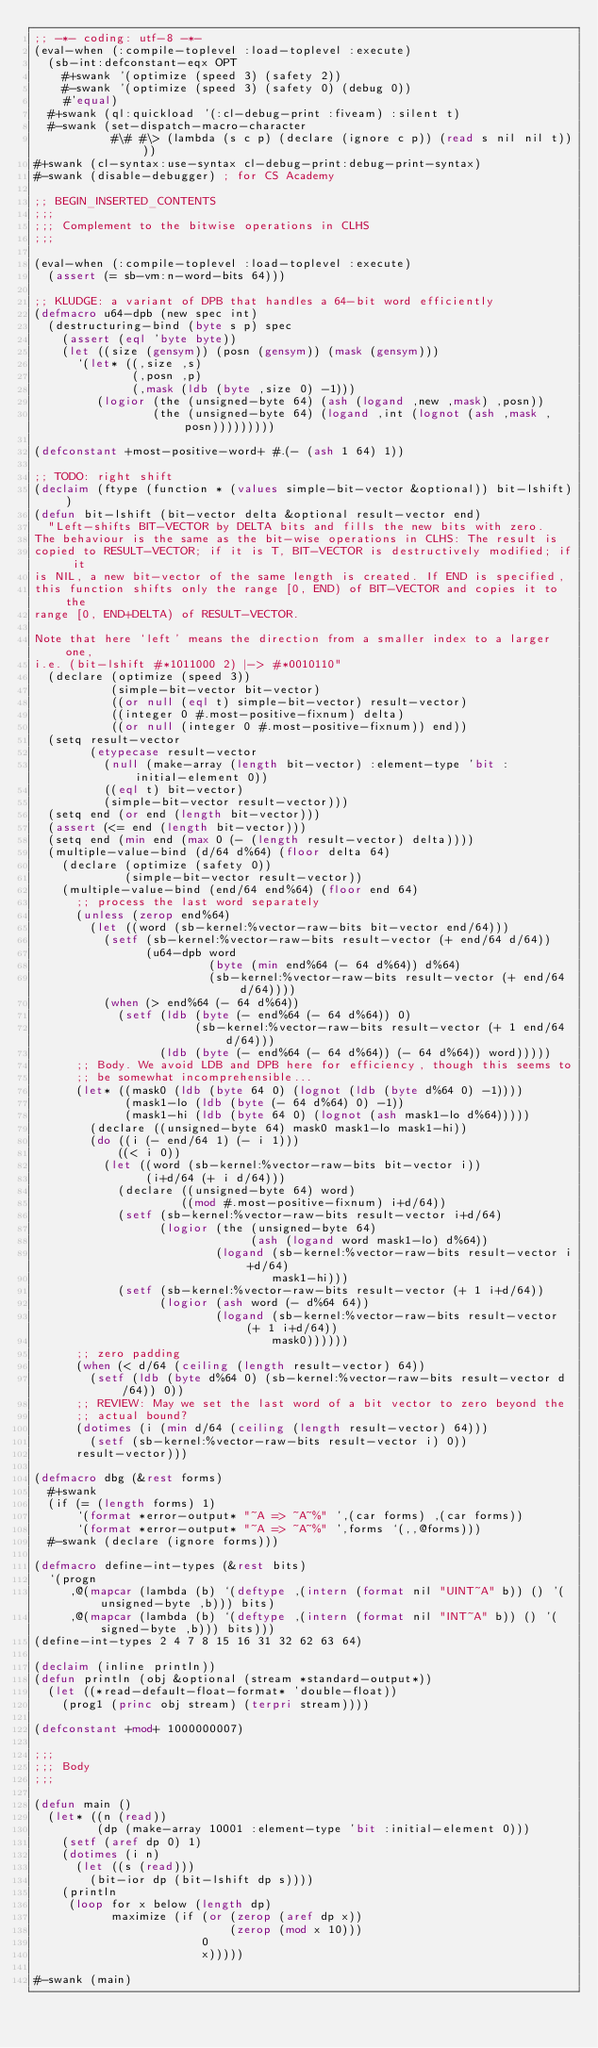Convert code to text. <code><loc_0><loc_0><loc_500><loc_500><_Lisp_>;; -*- coding: utf-8 -*-
(eval-when (:compile-toplevel :load-toplevel :execute)
  (sb-int:defconstant-eqx OPT
    #+swank '(optimize (speed 3) (safety 2))
    #-swank '(optimize (speed 3) (safety 0) (debug 0))
    #'equal)
  #+swank (ql:quickload '(:cl-debug-print :fiveam) :silent t)
  #-swank (set-dispatch-macro-character
           #\# #\> (lambda (s c p) (declare (ignore c p)) (read s nil nil t))))
#+swank (cl-syntax:use-syntax cl-debug-print:debug-print-syntax)
#-swank (disable-debugger) ; for CS Academy

;; BEGIN_INSERTED_CONTENTS
;;;
;;; Complement to the bitwise operations in CLHS
;;;

(eval-when (:compile-toplevel :load-toplevel :execute)
  (assert (= sb-vm:n-word-bits 64)))

;; KLUDGE: a variant of DPB that handles a 64-bit word efficiently
(defmacro u64-dpb (new spec int)
  (destructuring-bind (byte s p) spec
    (assert (eql 'byte byte))
    (let ((size (gensym)) (posn (gensym)) (mask (gensym)))
      `(let* ((,size ,s)
              (,posn ,p)
              (,mask (ldb (byte ,size 0) -1)))
         (logior (the (unsigned-byte 64) (ash (logand ,new ,mask) ,posn))
                 (the (unsigned-byte 64) (logand ,int (lognot (ash ,mask ,posn)))))))))

(defconstant +most-positive-word+ #.(- (ash 1 64) 1))

;; TODO: right shift
(declaim (ftype (function * (values simple-bit-vector &optional)) bit-lshift))
(defun bit-lshift (bit-vector delta &optional result-vector end)
  "Left-shifts BIT-VECTOR by DELTA bits and fills the new bits with zero.
The behaviour is the same as the bit-wise operations in CLHS: The result is
copied to RESULT-VECTOR; if it is T, BIT-VECTOR is destructively modified; if it
is NIL, a new bit-vector of the same length is created. If END is specified,
this function shifts only the range [0, END) of BIT-VECTOR and copies it to the
range [0, END+DELTA) of RESULT-VECTOR.

Note that here `left' means the direction from a smaller index to a larger one,
i.e. (bit-lshift #*1011000 2) |-> #*0010110"
  (declare (optimize (speed 3))
           (simple-bit-vector bit-vector)
           ((or null (eql t) simple-bit-vector) result-vector)
           ((integer 0 #.most-positive-fixnum) delta)
           ((or null (integer 0 #.most-positive-fixnum)) end))
  (setq result-vector
        (etypecase result-vector
          (null (make-array (length bit-vector) :element-type 'bit :initial-element 0))
          ((eql t) bit-vector)
          (simple-bit-vector result-vector)))
  (setq end (or end (length bit-vector)))
  (assert (<= end (length bit-vector)))
  (setq end (min end (max 0 (- (length result-vector) delta))))
  (multiple-value-bind (d/64 d%64) (floor delta 64)
    (declare (optimize (safety 0))
             (simple-bit-vector result-vector))
    (multiple-value-bind (end/64 end%64) (floor end 64)
      ;; process the last word separately
      (unless (zerop end%64)
        (let ((word (sb-kernel:%vector-raw-bits bit-vector end/64)))
          (setf (sb-kernel:%vector-raw-bits result-vector (+ end/64 d/64))
                (u64-dpb word
                         (byte (min end%64 (- 64 d%64)) d%64)
                         (sb-kernel:%vector-raw-bits result-vector (+ end/64 d/64))))
          (when (> end%64 (- 64 d%64))
            (setf (ldb (byte (- end%64 (- 64 d%64)) 0)
                       (sb-kernel:%vector-raw-bits result-vector (+ 1 end/64 d/64)))
                  (ldb (byte (- end%64 (- 64 d%64)) (- 64 d%64)) word)))))
      ;; Body. We avoid LDB and DPB here for efficiency, though this seems to
      ;; be somewhat incomprehensible...
      (let* ((mask0 (ldb (byte 64 0) (lognot (ldb (byte d%64 0) -1))))
             (mask1-lo (ldb (byte (- 64 d%64) 0) -1))
             (mask1-hi (ldb (byte 64 0) (lognot (ash mask1-lo d%64)))))
        (declare ((unsigned-byte 64) mask0 mask1-lo mask1-hi))
        (do ((i (- end/64 1) (- i 1)))
            ((< i 0))
          (let ((word (sb-kernel:%vector-raw-bits bit-vector i))
                (i+d/64 (+ i d/64)))
            (declare ((unsigned-byte 64) word)
                     ((mod #.most-positive-fixnum) i+d/64))
            (setf (sb-kernel:%vector-raw-bits result-vector i+d/64)
                  (logior (the (unsigned-byte 64)
                               (ash (logand word mask1-lo) d%64))
                          (logand (sb-kernel:%vector-raw-bits result-vector i+d/64)
                                  mask1-hi)))
            (setf (sb-kernel:%vector-raw-bits result-vector (+ 1 i+d/64))
                  (logior (ash word (- d%64 64))
                          (logand (sb-kernel:%vector-raw-bits result-vector (+ 1 i+d/64))
                                  mask0))))))
      ;; zero padding
      (when (< d/64 (ceiling (length result-vector) 64))
        (setf (ldb (byte d%64 0) (sb-kernel:%vector-raw-bits result-vector d/64)) 0))
      ;; REVIEW: May we set the last word of a bit vector to zero beyond the
      ;; actual bound?
      (dotimes (i (min d/64 (ceiling (length result-vector) 64)))
        (setf (sb-kernel:%vector-raw-bits result-vector i) 0))
      result-vector)))

(defmacro dbg (&rest forms)
  #+swank
  (if (= (length forms) 1)
      `(format *error-output* "~A => ~A~%" ',(car forms) ,(car forms))
      `(format *error-output* "~A => ~A~%" ',forms `(,,@forms)))
  #-swank (declare (ignore forms)))

(defmacro define-int-types (&rest bits)
  `(progn
     ,@(mapcar (lambda (b) `(deftype ,(intern (format nil "UINT~A" b)) () '(unsigned-byte ,b))) bits)
     ,@(mapcar (lambda (b) `(deftype ,(intern (format nil "INT~A" b)) () '(signed-byte ,b))) bits)))
(define-int-types 2 4 7 8 15 16 31 32 62 63 64)

(declaim (inline println))
(defun println (obj &optional (stream *standard-output*))
  (let ((*read-default-float-format* 'double-float))
    (prog1 (princ obj stream) (terpri stream))))

(defconstant +mod+ 1000000007)

;;;
;;; Body
;;;

(defun main ()
  (let* ((n (read))
         (dp (make-array 10001 :element-type 'bit :initial-element 0)))
    (setf (aref dp 0) 1)
    (dotimes (i n)
      (let ((s (read)))
        (bit-ior dp (bit-lshift dp s))))
    (println
     (loop for x below (length dp)
           maximize (if (or (zerop (aref dp x))
                            (zerop (mod x 10)))
                        0
                        x)))))

#-swank (main)
</code> 